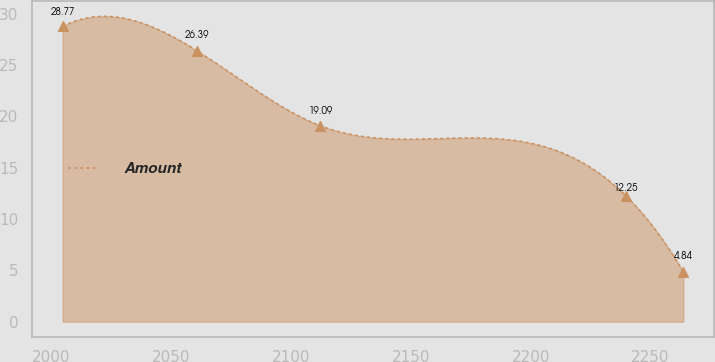Convert chart. <chart><loc_0><loc_0><loc_500><loc_500><line_chart><ecel><fcel>Amount<nl><fcel>2004.63<fcel>28.77<nl><fcel>2060.66<fcel>26.39<nl><fcel>2112.15<fcel>19.09<nl><fcel>2239.73<fcel>12.25<nl><fcel>2263.68<fcel>4.84<nl></chart> 